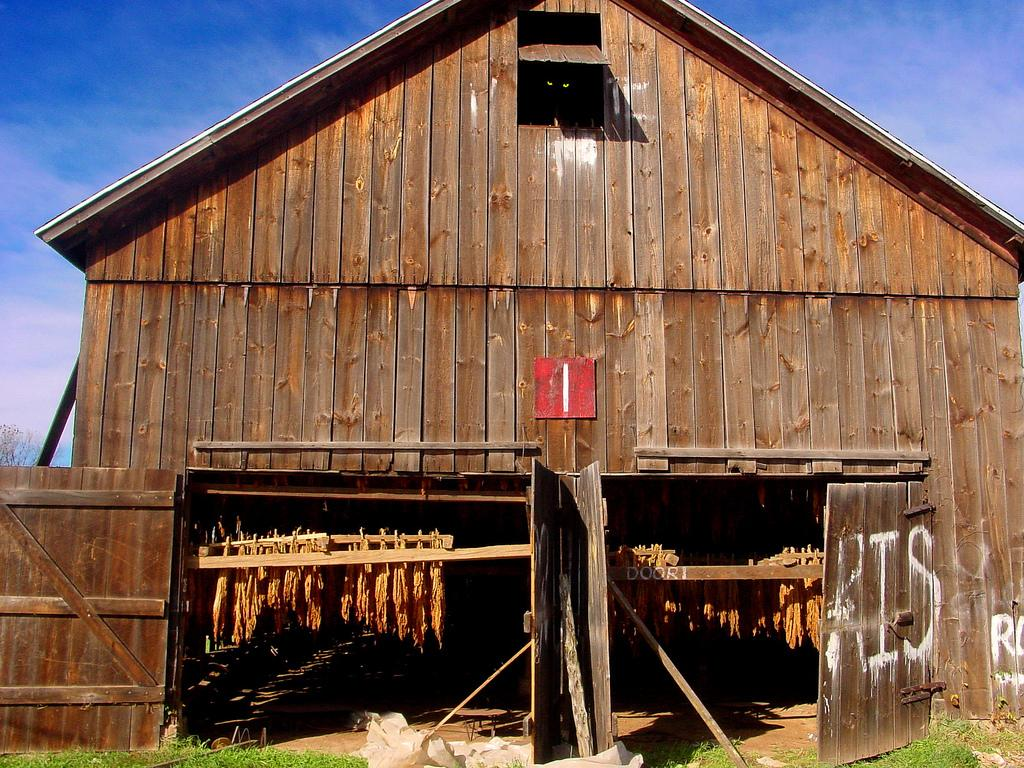What type of building is in the center of the image? There is a wooden cottage in the center of the image. What is covering the ground around the cottage? There is grass on the ground. What is the condition of the sky in the image? The sky is cloudy. What type of collar is visible on the wooden cottage in the image? There is no collar present on the wooden cottage in the image. 